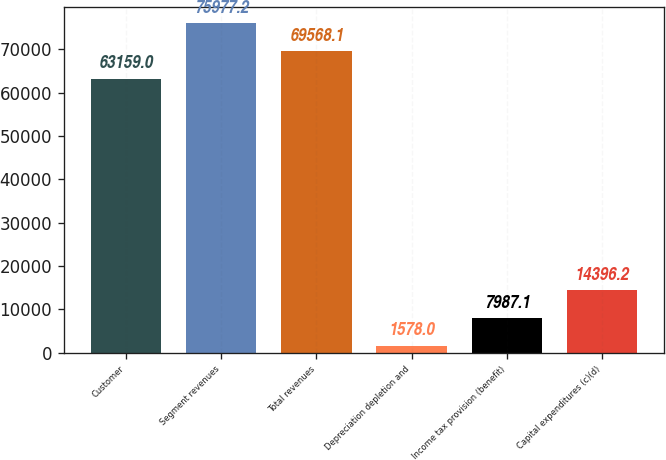Convert chart. <chart><loc_0><loc_0><loc_500><loc_500><bar_chart><fcel>Customer<fcel>Segment revenues<fcel>Total revenues<fcel>Depreciation depletion and<fcel>Income tax provision (benefit)<fcel>Capital expenditures (c)(d)<nl><fcel>63159<fcel>75977.2<fcel>69568.1<fcel>1578<fcel>7987.1<fcel>14396.2<nl></chart> 